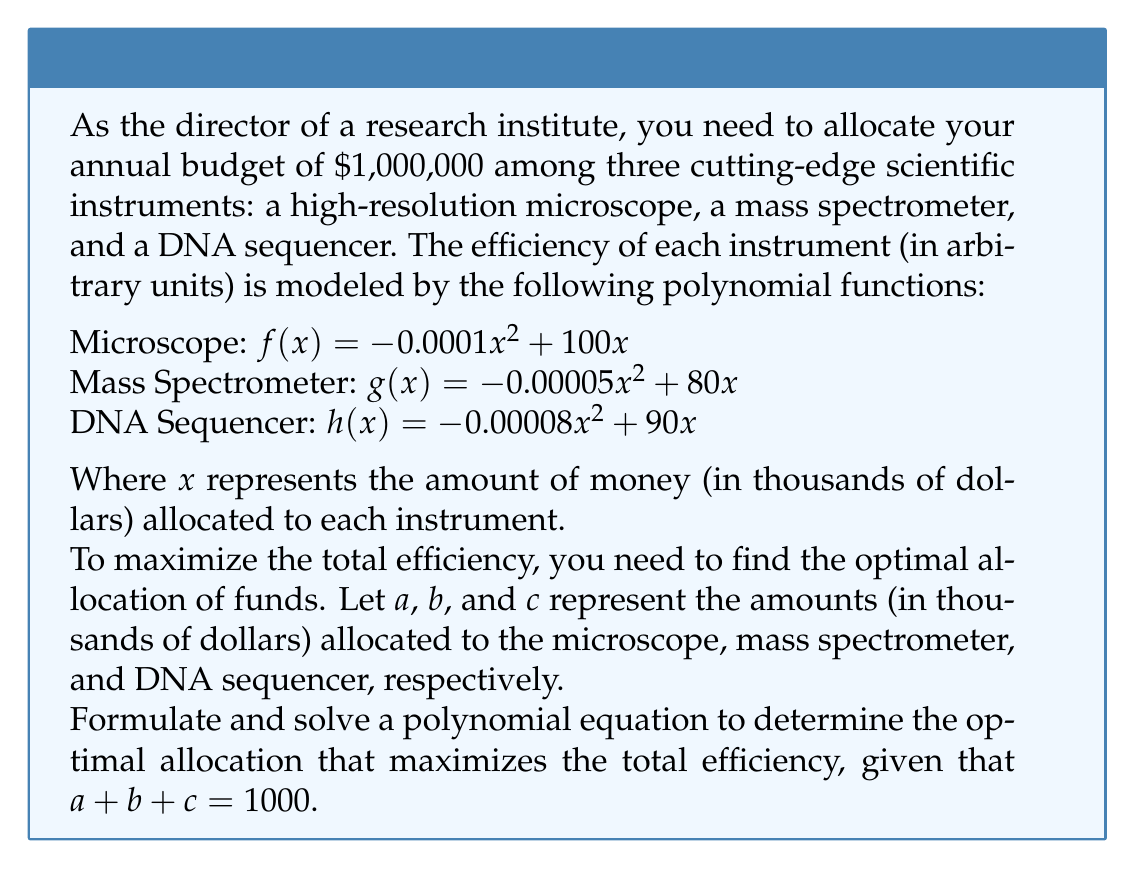Teach me how to tackle this problem. Let's approach this problem step-by-step:

1) The total efficiency is the sum of the efficiencies of all three instruments:

   $E_{total} = f(a) + g(b) + h(c)$

2) Substituting the given functions:

   $E_{total} = (-0.0001a^2 + 100a) + (-0.00005b^2 + 80b) + (-0.00008c^2 + 90c)$

3) We need to maximize this function subject to the constraint $a + b + c = 1000$. We can use the method of Lagrange multipliers. Let's define the Lagrangian:

   $L = (-0.0001a^2 + 100a) + (-0.00005b^2 + 80b) + (-0.00008c^2 + 90c) - \lambda(a + b + c - 1000)$

4) For the maximum, we set the partial derivatives equal to zero:

   $\frac{\partial L}{\partial a} = -0.0002a + 100 - \lambda = 0$
   $\frac{\partial L}{\partial b} = -0.0001b + 80 - \lambda = 0$
   $\frac{\partial L}{\partial c} = -0.00016c + 90 - \lambda = 0$
   $\frac{\partial L}{\partial \lambda} = a + b + c - 1000 = 0$

5) From these equations, we can derive:

   $a = 500000 - 5000\lambda$
   $b = 800000 - 10000\lambda$
   $c = 562500 - 6250\lambda$

6) Substituting these into the constraint equation:

   $(500000 - 5000\lambda) + (800000 - 10000\lambda) + (562500 - 6250\lambda) = 1000000$

7) Simplifying:

   $1862500 - 21250\lambda = 1000000$
   $862500 = 21250\lambda$
   $\lambda = 40.5882$

8) Now we can solve for $a$, $b$, and $c$:

   $a = 500000 - 5000(40.5882) = 297,059$
   $b = 800000 - 10000(40.5882) = 394,118$
   $c = 562500 - 6250(40.5882) = 308,823$

9) Rounding to the nearest thousand (as the question specifies amounts in thousands of dollars):

   $a = 297$, $b = 394$, $c = 309$
Answer: The optimal allocation to maximize total efficiency is:

Microscope: $297,000
Mass Spectrometer: $394,000
DNA Sequencer: $309,000 